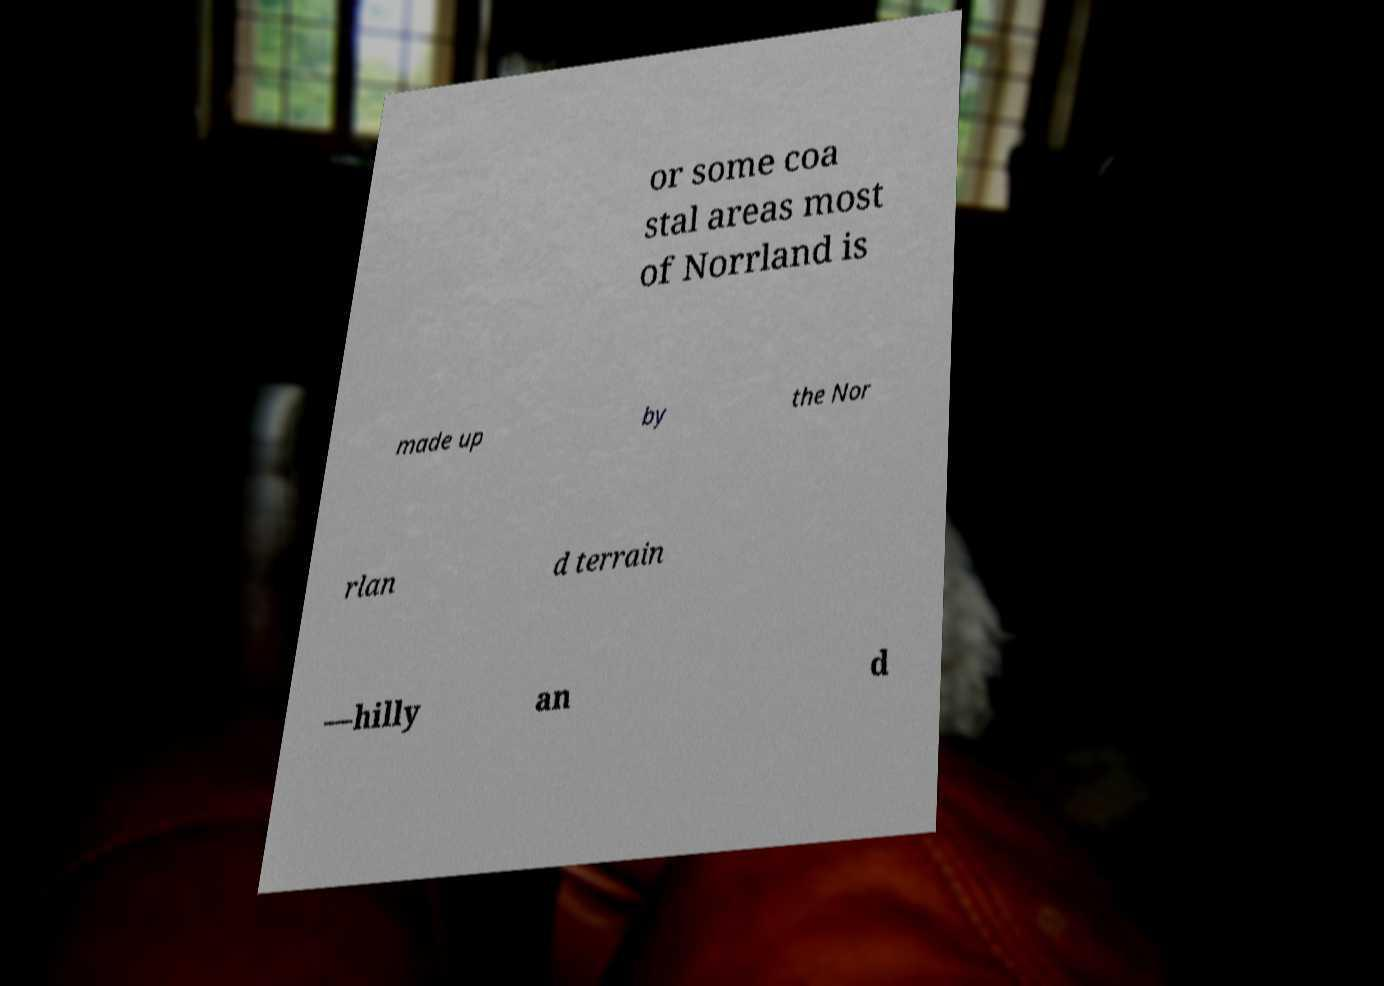Could you extract and type out the text from this image? or some coa stal areas most of Norrland is made up by the Nor rlan d terrain —hilly an d 